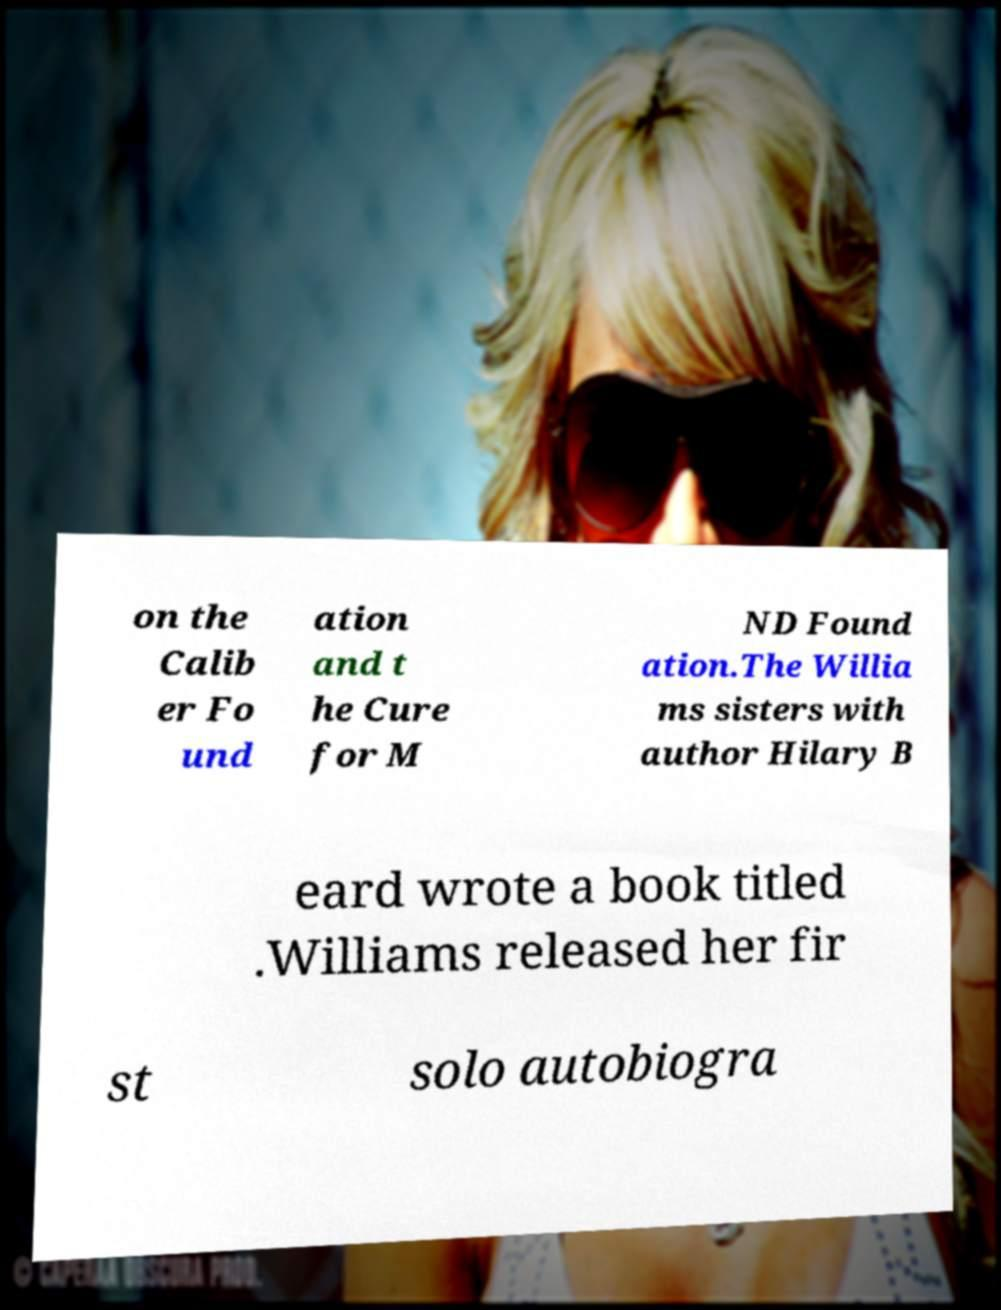There's text embedded in this image that I need extracted. Can you transcribe it verbatim? on the Calib er Fo und ation and t he Cure for M ND Found ation.The Willia ms sisters with author Hilary B eard wrote a book titled .Williams released her fir st solo autobiogra 